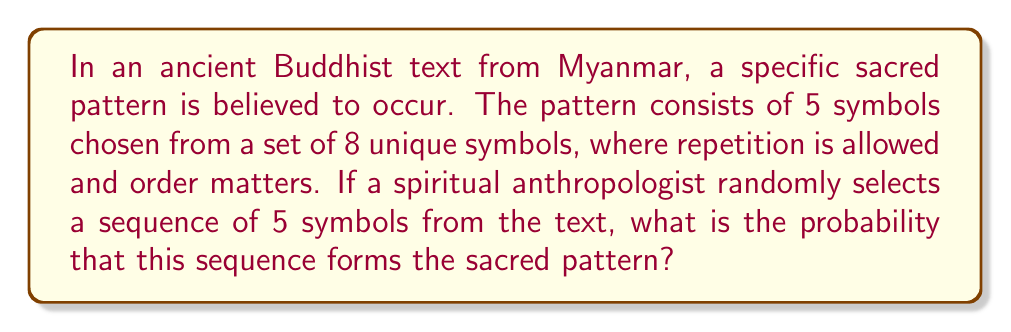Can you answer this question? To solve this problem, we need to use the principles of combinatorics and probability theory. Let's break it down step by step:

1. First, we need to calculate the total number of possible 5-symbol sequences that can be formed from 8 symbols, with repetition allowed and order mattering. This is a case of permutation with repetition.

   Total number of possible sequences = $8^5$

   This is because for each of the 5 positions, we have 8 choices, and the choices are independent of each other.

2. Now, we need to consider the probability of randomly selecting the specific sacred pattern. Since there is only one correct sequence that forms the sacred pattern, there is only one favorable outcome.

3. The probability of an event is calculated by dividing the number of favorable outcomes by the total number of possible outcomes:

   $$P(\text{sacred pattern}) = \frac{\text{number of favorable outcomes}}{\text{total number of possible outcomes}}$$

4. Substituting our values:

   $$P(\text{sacred pattern}) = \frac{1}{8^5} = \frac{1}{32768}$$

5. To express this as a decimal, we can perform the division:

   $$\frac{1}{32768} \approx 0.0000305176$$

Therefore, the probability of randomly selecting the sacred pattern is approximately 0.0000305176 or about 0.00305176%.
Answer: $$\frac{1}{32768} \approx 0.0000305176$$ 